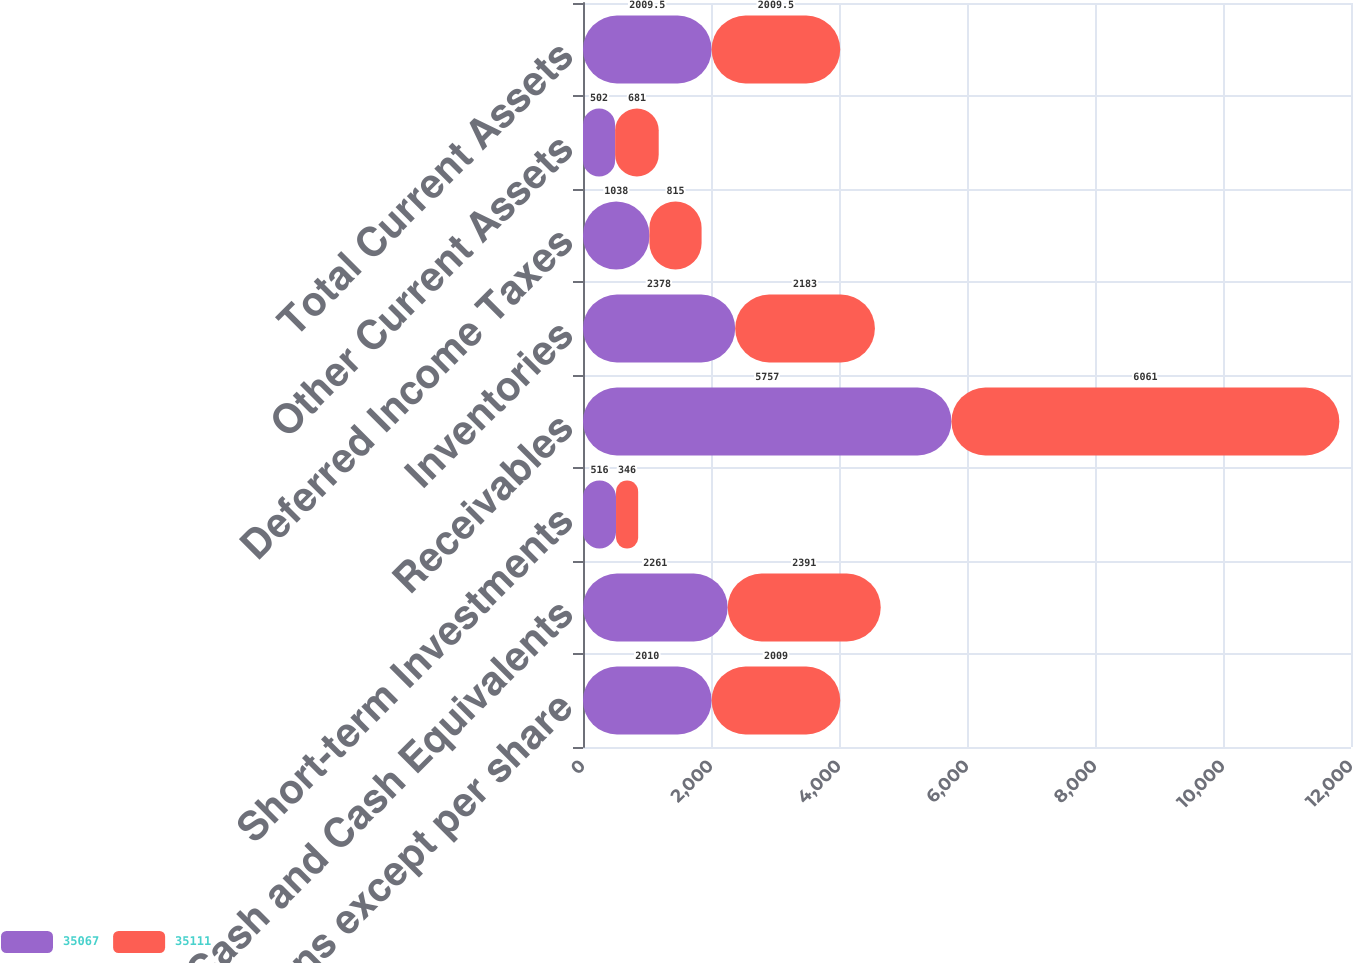Convert chart. <chart><loc_0><loc_0><loc_500><loc_500><stacked_bar_chart><ecel><fcel>(In millions except per share<fcel>Cash and Cash Equivalents<fcel>Short-term Investments<fcel>Receivables<fcel>Inventories<fcel>Deferred Income Taxes<fcel>Other Current Assets<fcel>Total Current Assets<nl><fcel>35067<fcel>2010<fcel>2261<fcel>516<fcel>5757<fcel>2378<fcel>1038<fcel>502<fcel>2009.5<nl><fcel>35111<fcel>2009<fcel>2391<fcel>346<fcel>6061<fcel>2183<fcel>815<fcel>681<fcel>2009.5<nl></chart> 